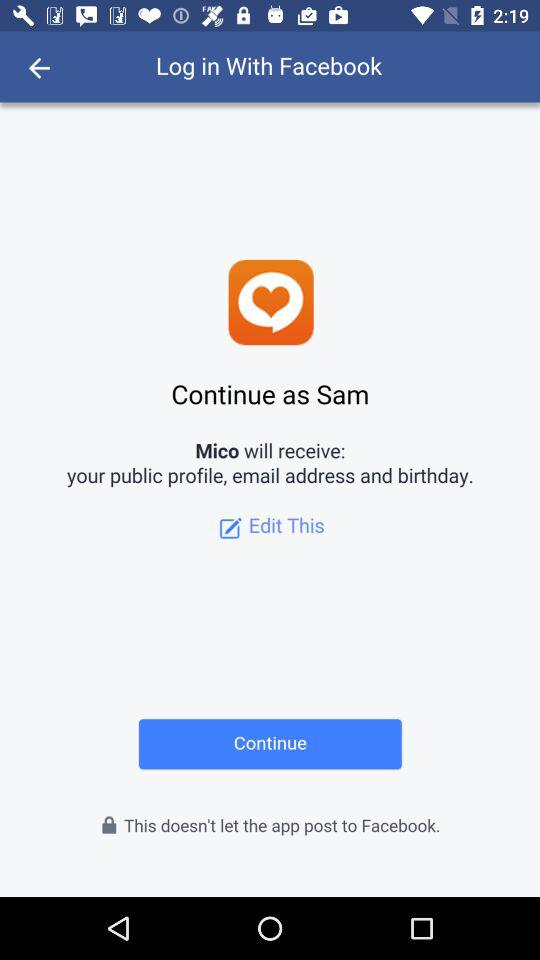With what application can we log in? You can log in with the "Facebook" application. 